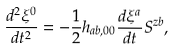<formula> <loc_0><loc_0><loc_500><loc_500>\frac { d ^ { 2 } \xi ^ { 0 } } { d t ^ { 2 } } = - \frac { 1 } { 2 } h _ { a b , 0 0 } \frac { d \xi ^ { a } } { d t } S ^ { z b } ,</formula> 